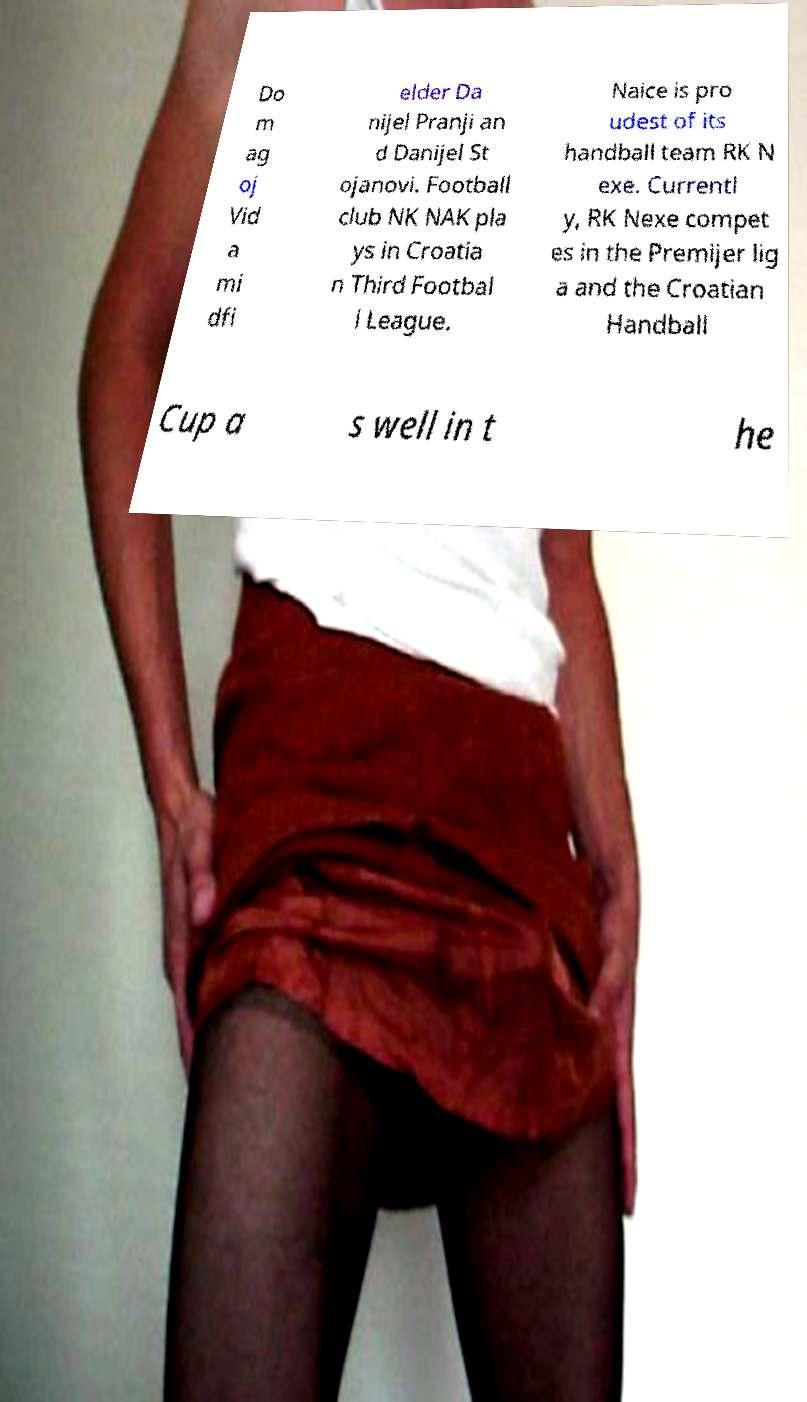Could you assist in decoding the text presented in this image and type it out clearly? Do m ag oj Vid a mi dfi elder Da nijel Pranji an d Danijel St ojanovi. Football club NK NAK pla ys in Croatia n Third Footbal l League. Naice is pro udest of its handball team RK N exe. Currentl y, RK Nexe compet es in the Premijer lig a and the Croatian Handball Cup a s well in t he 